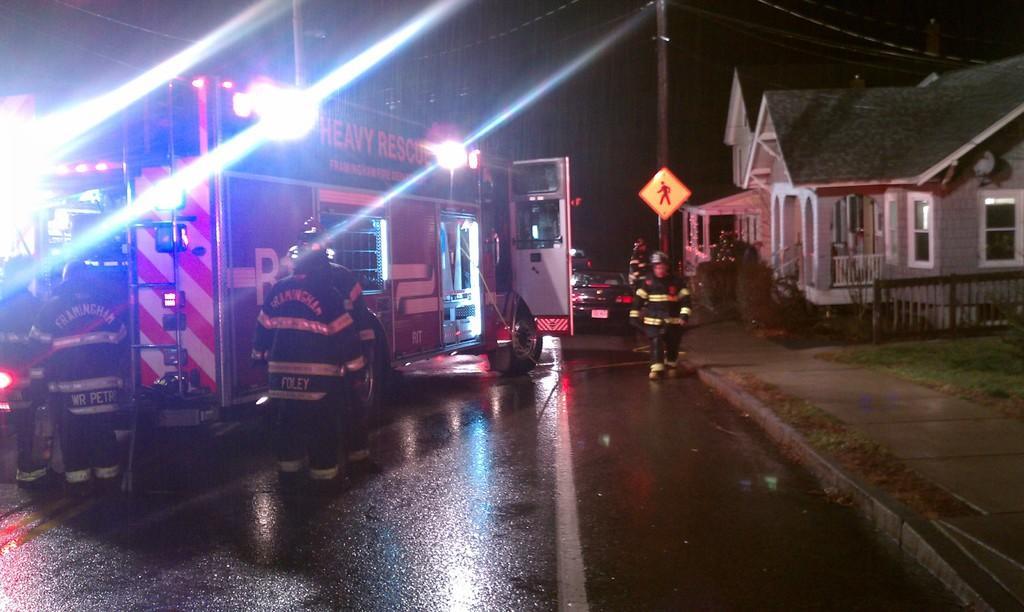Please provide a concise description of this image. this picture shows a rescue truck parked ,we can see the employees standing out side the truck and a car parked on the road and a house 